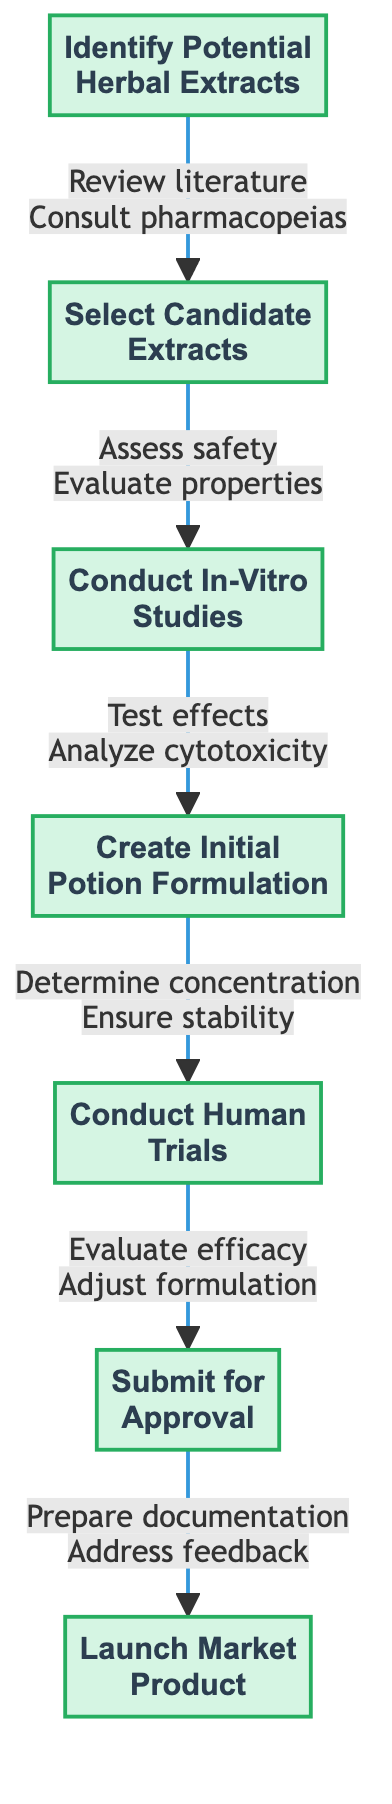What is the first step in the clinical pathway? The first step in the pathway is "Identify Potential Herbal Extracts," as it is the starting node in the diagram.
Answer: Identify Potential Herbal Extracts How many main steps are there in the clinical pathway? The diagram shows a total of seven main steps, each represented as nodes in the flowchart.
Answer: 7 Which step follows "Conduct In-Vitro Studies"? The flowchart indicates that "Create Initial Potion Formulation" is the step that follows "Conduct In-Vitro Studies."
Answer: Create Initial Potion Formulation What action is associated with the "Select Candidate Extracts" step? The actions listed for this step include "Assess safety profiles," which is one of the actions clearly linked to that node.
Answer: Assess safety profiles What is the last step of the clinical pathway? The final step in the pathway, as depicted in the diagram, is "Launch Market Product."
Answer: Launch Market Product What is one action taken during "Conduct Human Trials"? One action during this step is to "Evaluate efficacy and side effects," which shows what is done during the human trials.
Answer: Evaluate efficacy and side effects What step involves preparing documentation? The step titled "Submit for Approval" includes the action of preparing documentation, indicating what needs to be done in that step.
Answer: Submit for Approval How does the clinical pathway ensure user feedback is collected? "Launch Market Product" contains an action to "Collect user feedback for improvements," which ensures feedback is gathered post-launch.
Answer: Collect user feedback for improvements What actions are taken during the "Create Initial Potion Formulation" step? The actions listed are "Determine appropriate extract concentration," "Combine with base ingredients," and "Ensure stability and solubility," all relevant to this formulation step.
Answer: Determine appropriate extract concentration, Combine with base ingredients, Ensure stability and solubility 